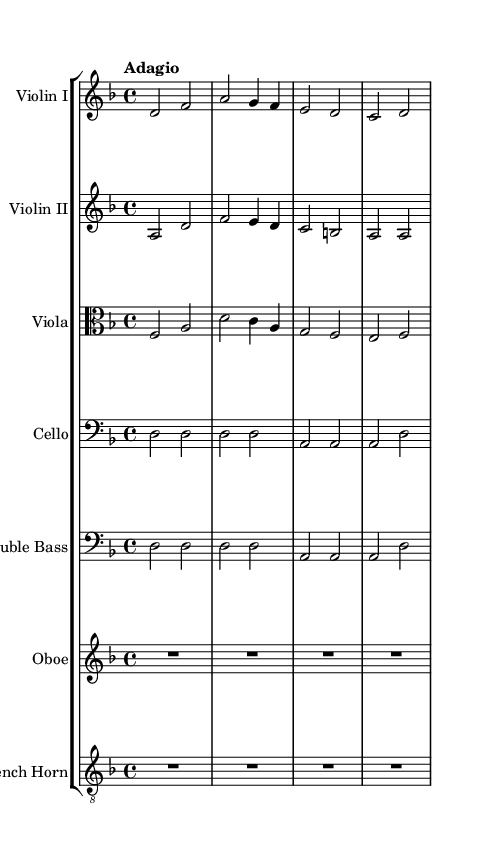What is the key signature of this music? The key signature is indicated at the beginning of the staff. Here, it shows two flats, which correspond to D minor, as D minor is the relative minor of F major, which has one flat.
Answer: D minor What is the time signature of this piece? The time signature is depicted at the beginning of the score, next to the key signature. It shows 4/4, meaning there are four beats per measure, and the quarter note receives one beat.
Answer: 4/4 What is the tempo marking for this piece? The tempo marking is found above the staff indicating the speed of the piece. It says "Adagio," which translates to a slow tempo.
Answer: Adagio Which instrument is not playing in the first measure? The first measure is shown horizontally across all staff lines. By reviewing them, we see that the Oboe and French Horn do not have any notes in the first measure, meaning they are resting.
Answer: Oboe and French Horn How many measures are in this excerpt? A measure is defined by the vertical lines separating the musical notes. Counting the vertical lines in this music, there are four measures presented in this example.
Answer: Four What is the last note played by the Violin II? By reading the Violin II part, the last note is in the last measure, where it is an A, as indicated in the score.
Answer: A Which string instrument has the same notes in the first two measures? Looking closely at the Cello and Double Bass parts, they both play D in the first two measures. This indicates they have the same notes for those measures.
Answer: Cello and Double Bass 